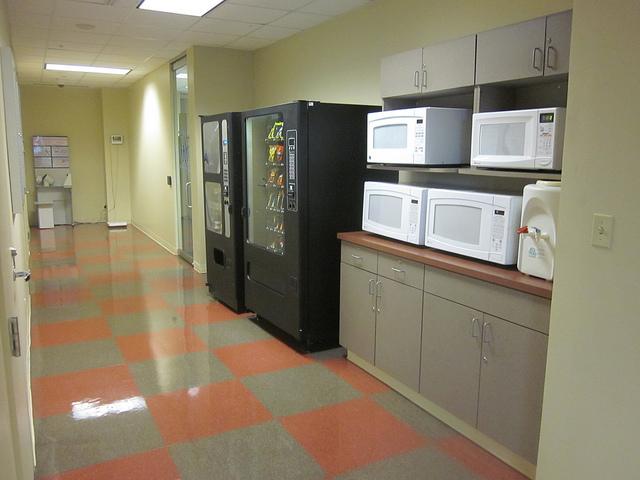Is this a conventional apartment?
Be succinct. No. How many microwaves are there?
Be succinct. 4. Is there a shower?
Give a very brief answer. No. What kind of tiles are there?
Short answer required. Vinyl. Are these appliances modern?
Quick response, please. Yes. How many cabinets are there?
Give a very brief answer. 8. Is there a built-in oven in this kitchen?
Quick response, please. No. How many vending machines are in this room?
Quick response, please. 2. Would this be in a workplace?
Answer briefly. Yes. 